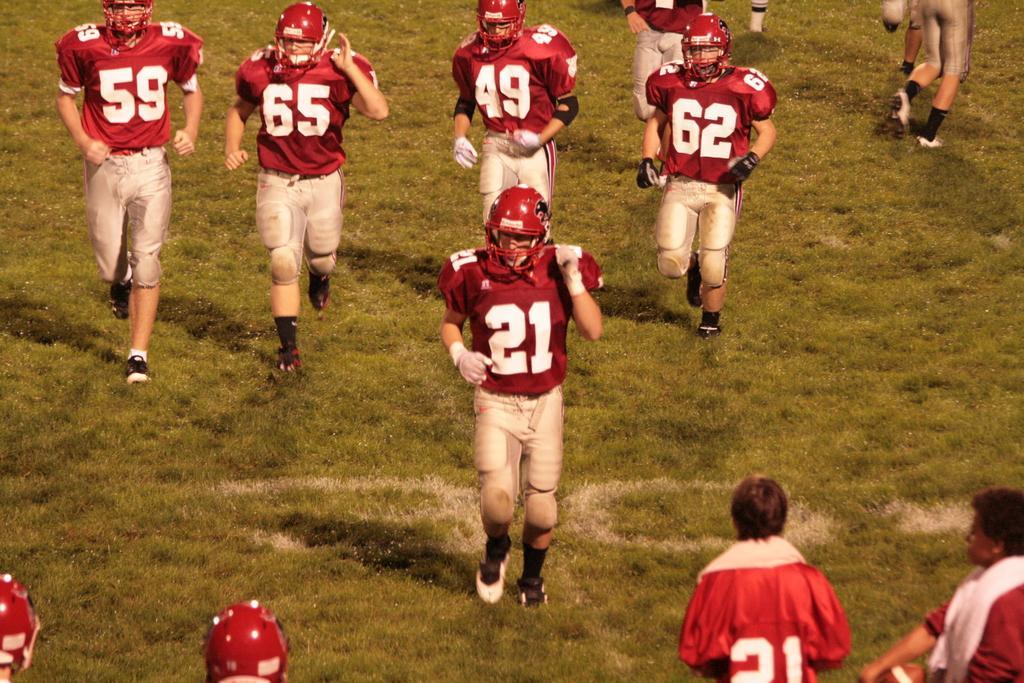Can you describe this image briefly? This picture is clicked outside. In the center we can see the group of persons wearing t-shirts, helmets and running on the ground and we can see the green grass. In the foreground we can see the two persons. 